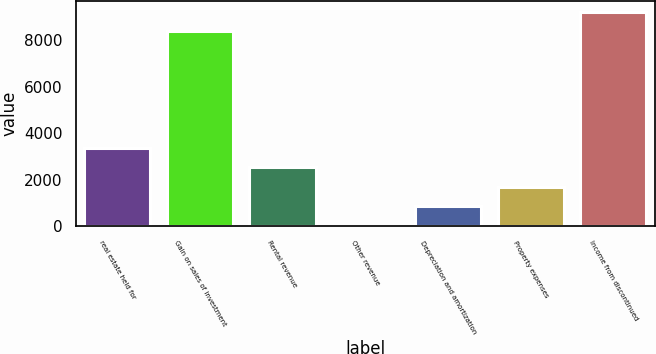<chart> <loc_0><loc_0><loc_500><loc_500><bar_chart><fcel>real estate held for<fcel>Gain on sales of investment<fcel>Rental revenue<fcel>Other revenue<fcel>Depreciation and amortization<fcel>Property expenses<fcel>Income from discontinued<nl><fcel>3388<fcel>8405<fcel>2549<fcel>32<fcel>871<fcel>1710<fcel>9244<nl></chart> 